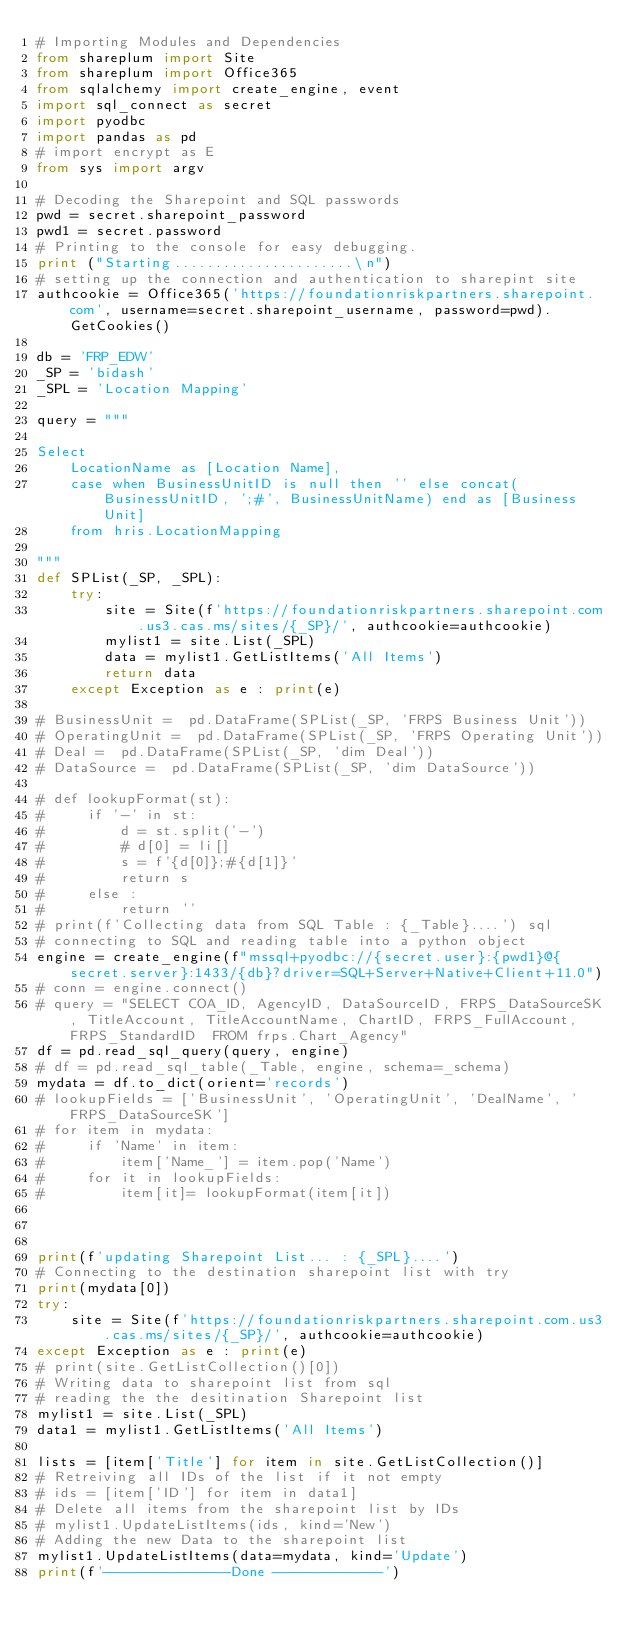<code> <loc_0><loc_0><loc_500><loc_500><_Python_># Importing Modules and Dependencies 
from shareplum import Site
from shareplum import Office365
from sqlalchemy import create_engine, event
import sql_connect as secret
import pyodbc
import pandas as pd
# import encrypt as E
from sys import argv

# Decoding the Sharepoint and SQL passwords
pwd = secret.sharepoint_password
pwd1 = secret.password
# Printing to the console for easy debugging.
print ("Starting......................\n")
# setting up the connection and authentication to sharepint site
authcookie = Office365('https://foundationriskpartners.sharepoint.com', username=secret.sharepoint_username, password=pwd).GetCookies()

db = 'FRP_EDW'
_SP = 'bidash'
_SPL = 'Location Mapping'

query = """  

Select 
	LocationName as [Location Name], 
	case when BusinessUnitID is null then '' else concat(BusinessUnitID, ';#', BusinessUnitName) end as [Business Unit] 
	from hris.LocationMapping

"""
def SPList(_SP, _SPL):
    try:
        site = Site(f'https://foundationriskpartners.sharepoint.com.us3.cas.ms/sites/{_SP}/', authcookie=authcookie)
        mylist1 = site.List(_SPL)
        data = mylist1.GetListItems('All Items')
        return data
    except Exception as e : print(e)

# BusinessUnit =  pd.DataFrame(SPList(_SP, 'FRPS Business Unit'))
# OperatingUnit =  pd.DataFrame(SPList(_SP, 'FRPS Operating Unit'))
# Deal =  pd.DataFrame(SPList(_SP, 'dim Deal'))
# DataSource =  pd.DataFrame(SPList(_SP, 'dim DataSource'))

# def lookupFormat(st):
#     if '-' in st:
#         d = st.split('-')
#         # d[0] = li[]
#         s = f'{d[0]};#{d[1]}'
#         return s
#     else :
#         return ''
# print(f'Collecting data from SQL Table : {_Table}....') sql       
# connecting to SQL and reading table into a python object
engine = create_engine(f"mssql+pyodbc://{secret.user}:{pwd1}@{secret.server}:1433/{db}?driver=SQL+Server+Native+Client+11.0")
# conn = engine.connect()
# query = "SELECT COA_ID, AgencyID, DataSourceID, FRPS_DataSourceSK, TitleAccount, TitleAccountName, ChartID, FRPS_FullAccount, FRPS_StandardID  FROM frps.Chart_Agency"
df = pd.read_sql_query(query, engine)
# df = pd.read_sql_table(_Table, engine, schema=_schema)
mydata = df.to_dict(orient='records')
# lookupFields = ['BusinessUnit', 'OperatingUnit', 'DealName', 'FRPS_DataSourceSK']
# for item in mydata:
#     if 'Name' in item:
#         item['Name_'] = item.pop('Name')
#     for it in lookupFields:
#         item[it]= lookupFormat(item[it])
    
   

print(f'updating Sharepoint List... : {_SPL}....')
# Connecting to the destination sharepoint list with try 
print(mydata[0])
try:
    site = Site(f'https://foundationriskpartners.sharepoint.com.us3.cas.ms/sites/{_SP}/', authcookie=authcookie)
except Exception as e : print(e)
# print(site.GetListCollection()[0])
# Writing data to sharepoint list from sql
# reading the the desitination Sharepoint list
mylist1 = site.List(_SPL)
data1 = mylist1.GetListItems('All Items')

lists = [item['Title'] for item in site.GetListCollection()]
# Retreiving all IDs of the list if it not empty
# ids = [item['ID'] for item in data1]
# Delete all items from the sharepoint list by IDs
# mylist1.UpdateListItems(ids, kind='New')
# Adding the new Data to the sharepoint list 
mylist1.UpdateListItems(data=mydata, kind='Update')
print(f'---------------Done -------------')



</code> 